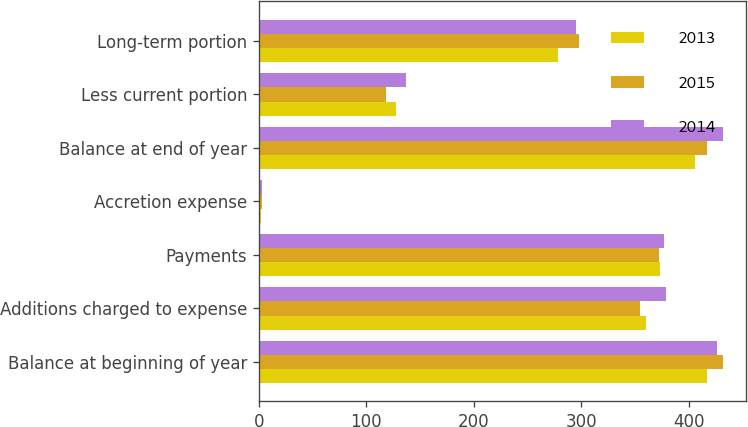Convert chart to OTSL. <chart><loc_0><loc_0><loc_500><loc_500><stacked_bar_chart><ecel><fcel>Balance at beginning of year<fcel>Additions charged to expense<fcel>Payments<fcel>Accretion expense<fcel>Balance at end of year<fcel>Less current portion<fcel>Long-term portion<nl><fcel>2013<fcel>416.6<fcel>360.4<fcel>373.1<fcel>1.9<fcel>405.8<fcel>127.7<fcel>278.1<nl><fcel>2015<fcel>431.5<fcel>354.8<fcel>372.2<fcel>2.5<fcel>416.6<fcel>118.6<fcel>298<nl><fcel>2014<fcel>426.4<fcel>379.1<fcel>377.2<fcel>3.2<fcel>431.5<fcel>136.6<fcel>294.9<nl></chart> 